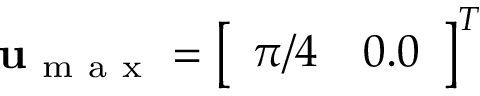<formula> <loc_0><loc_0><loc_500><loc_500>u _ { m a x } = \left [ \begin{array} { l l } { \pi / 4 } & { 0 . 0 } \end{array} \right ] ^ { T }</formula> 